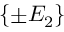Convert formula to latex. <formula><loc_0><loc_0><loc_500><loc_500>\{ \pm E _ { 2 } \}</formula> 